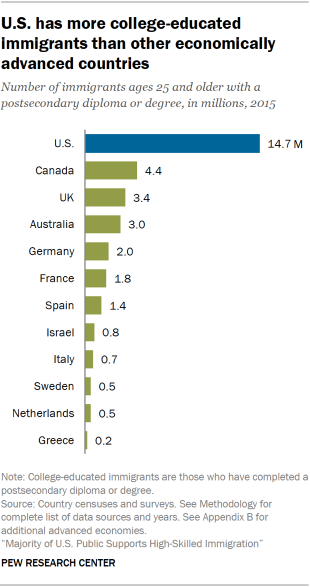Specify some key components in this picture. The median of the green bars is 1.4. What is the value of the second bar from the bottom, which is 0.5? 